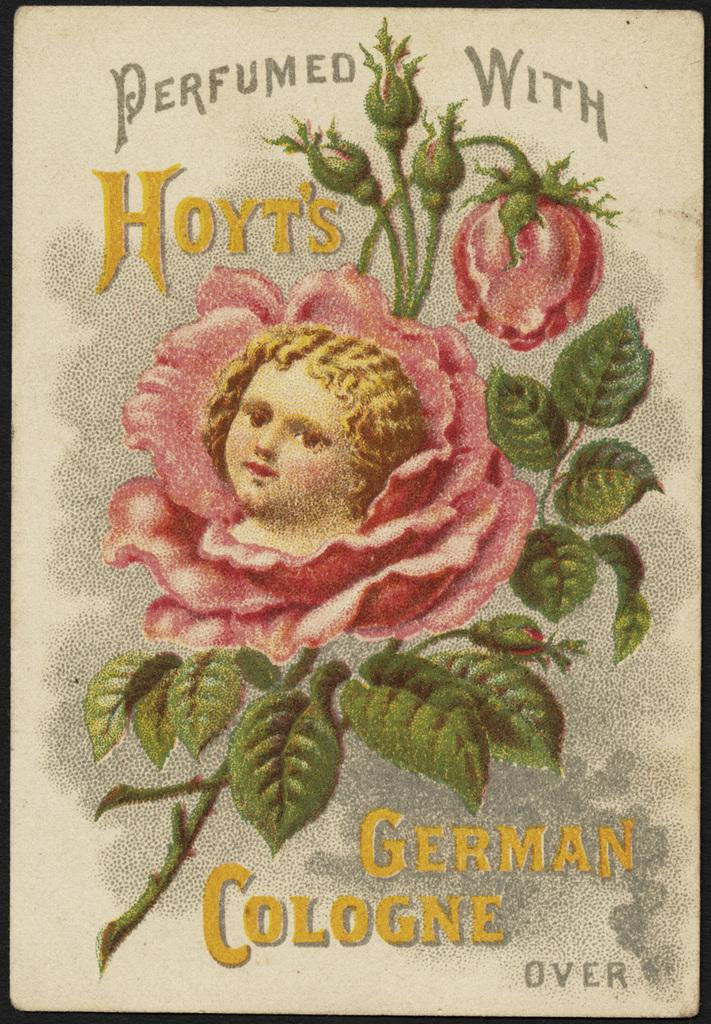What is featured on the poster in the image? There is a poster in the image that contains text and a picture of a child. What other element is present on the poster? There is a pink color flower with buds on the poster. Can you tell me how many women are depicted on the poster? There is no woman depicted on the poster; it features a picture of a child and a pink flower with buds. What type of coast can be seen in the image? There is no coast present in the image; it features a poster with text, a picture of a child, and a pink flower with buds. 